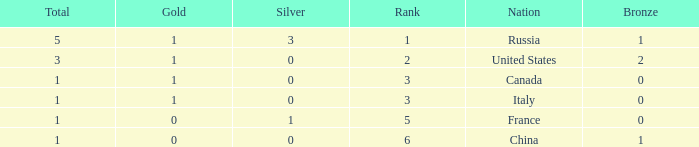Name the total number of ranks when total is less than 1 0.0. 